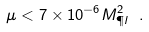Convert formula to latex. <formula><loc_0><loc_0><loc_500><loc_500>\mu < 7 \times 1 0 ^ { - 6 } M _ { \P l } ^ { 2 } \ .</formula> 